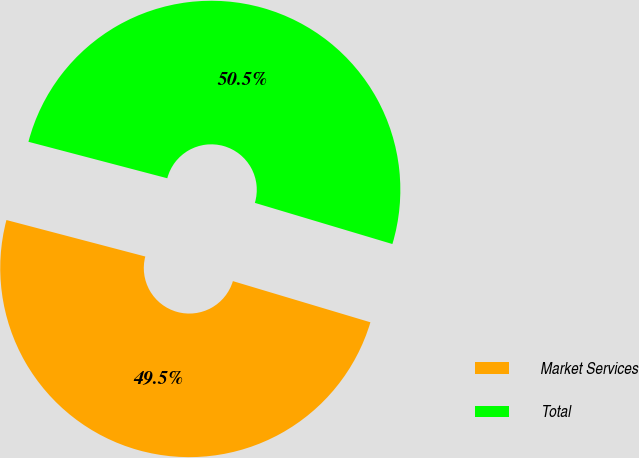Convert chart. <chart><loc_0><loc_0><loc_500><loc_500><pie_chart><fcel>Market Services<fcel>Total<nl><fcel>49.46%<fcel>50.54%<nl></chart> 